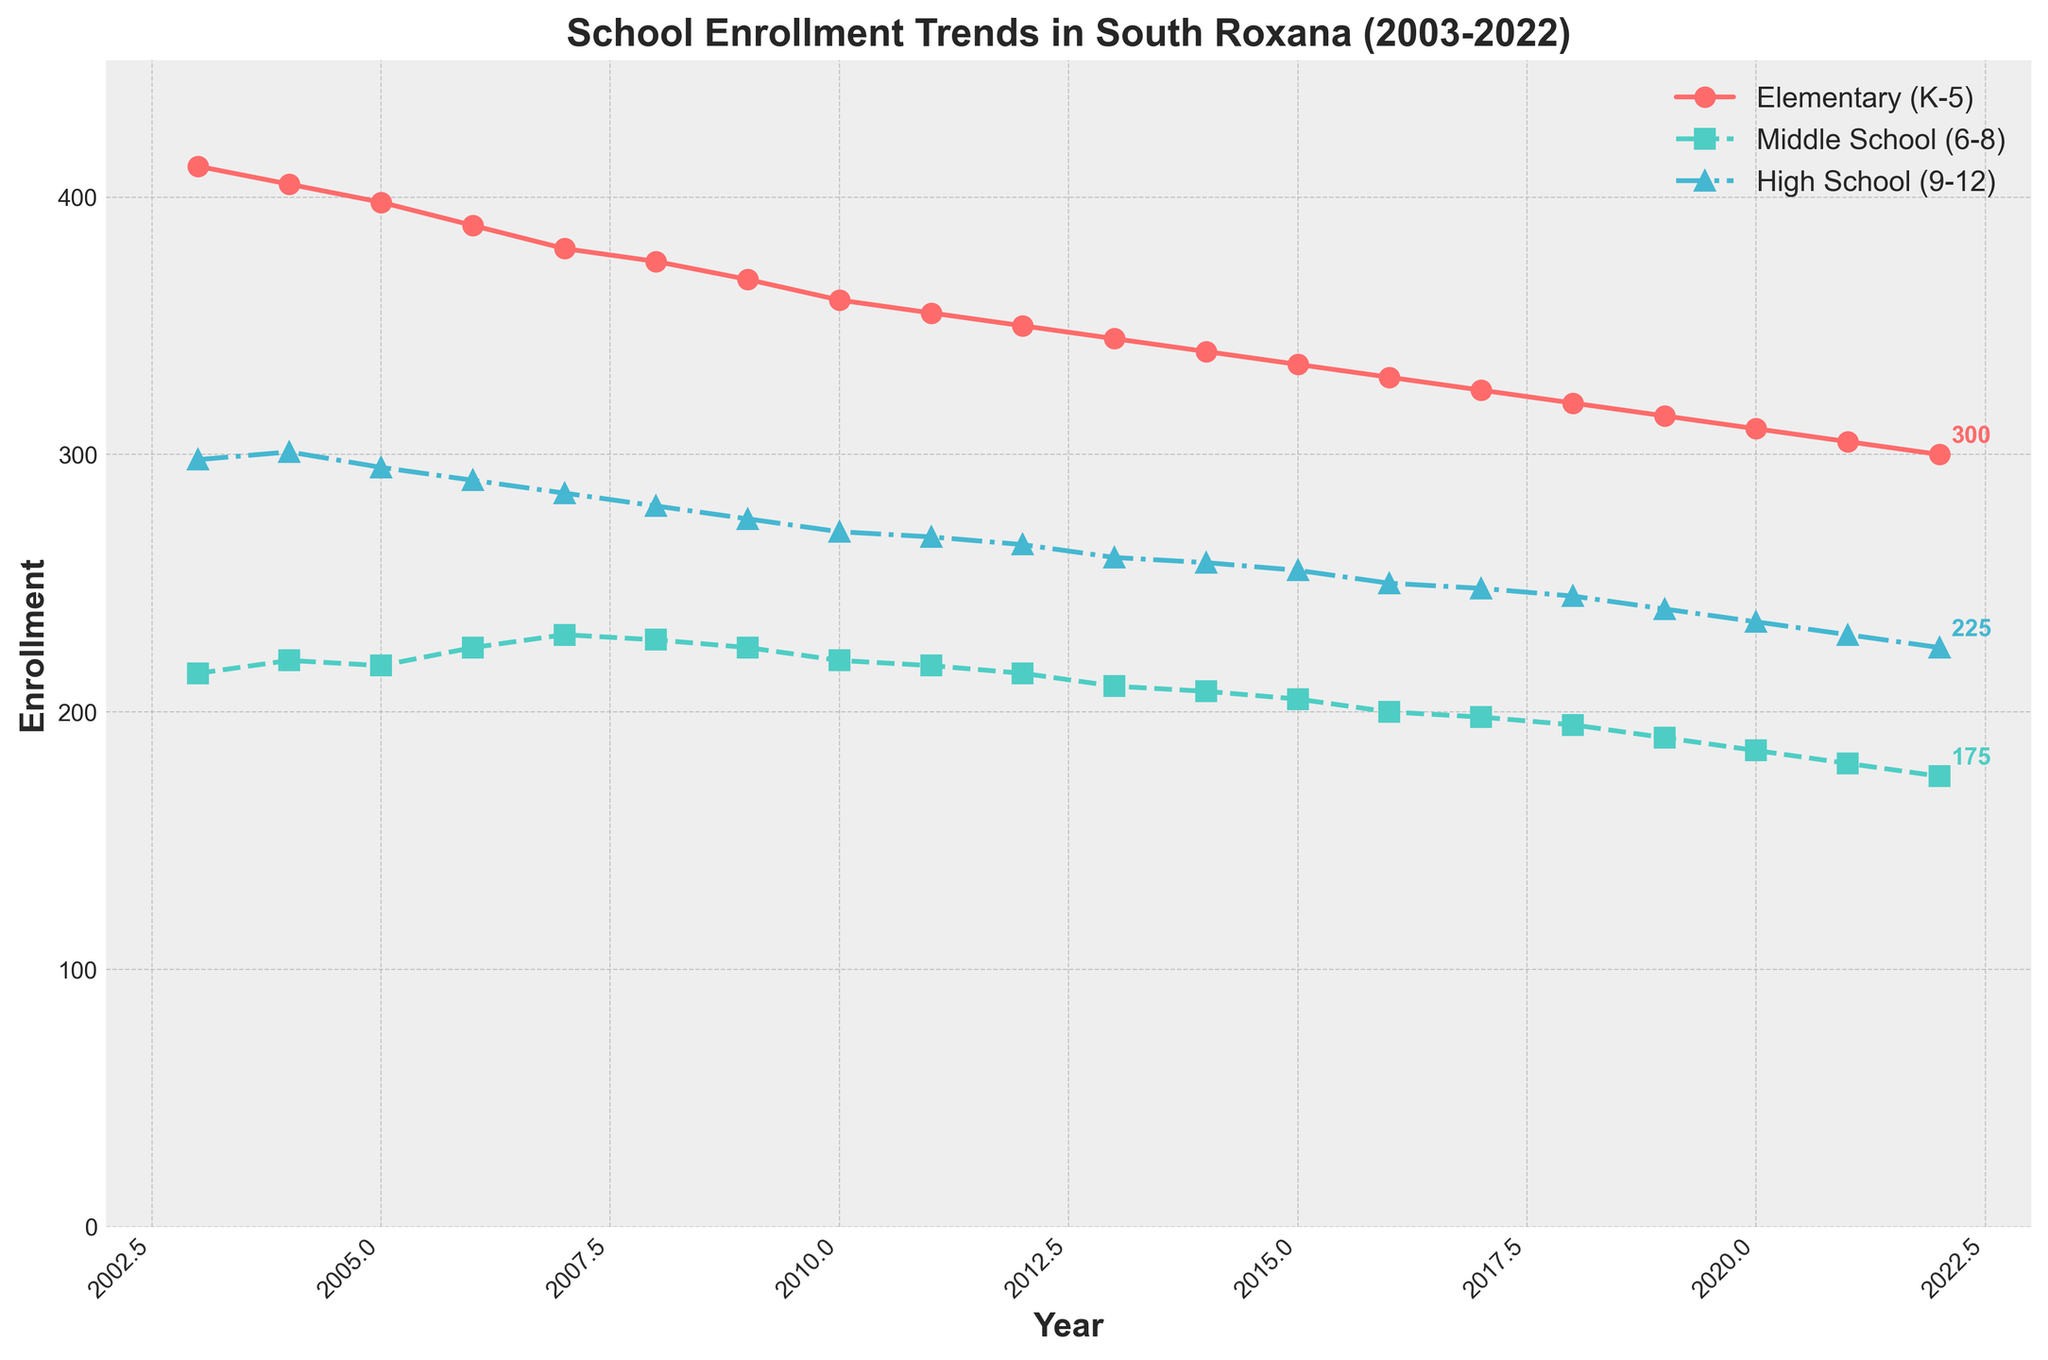When did the enrollment in Elementary (K-5) drop below 350? The enrollment in Elementary (K-5) dropped below 350 in the year 2012. By checking the data points on the Elementary (K-5) line, we can see that the enrollment was at 350 in 2012 and decreased to 345 in 2013.
Answer: 2013 How many times did the Middle School (6-8) enrollment either increase or stay the same from one year to the next? Examine the Middle School (6-8) line. Count the number of years where the enrollment either went up or remained the same compared to the previous year. Those years are 2004, 2006, and 2007.
Answer: 3 What is the difference in enrollment between Elementary (K-5) and High School (9-12) in 2018? Look at the data for the year 2018. For Elementary, the enrollment was 320. For High School, it was 245. Subtract the High School number from the Elementary number: 320 - 245 = 75.
Answer: 75 Between which two consecutive years did the High School (9-12) enrollment decrease the most? By examining the High School (9-12) line, identify the largest drop between two consecutive years. The largest decrease happened between the years 2009 and 2010 with a drop from 275 to 270, which is a 5-student decrease.
Answer: 2009 and 2010 In what year was the enrollment gap between Elementary (K-5) and Middle School (6-8) the smallest? Calculate the yearly differences between the Elementary (K-5) and Middle School (6-8) enrollments. The smallest gap occurred in 2007, where the difference is 380 - 230 = 150.
Answer: 2007 Which grade level had the least volatile enrollment trend over the 20 years? A visual inspection of the lines indicates that the High School (9-12) trend has the smallest slope and fewer fluctuations compared to Elementary and Middle School. Thus, it had the least volatility.
Answer: High School (9-12) What color represents the Middle School (6-8) enrollment line? By referring to the legend in the figure, we see that the Middle School (6-8) line is represented by the green color.
Answer: Green 